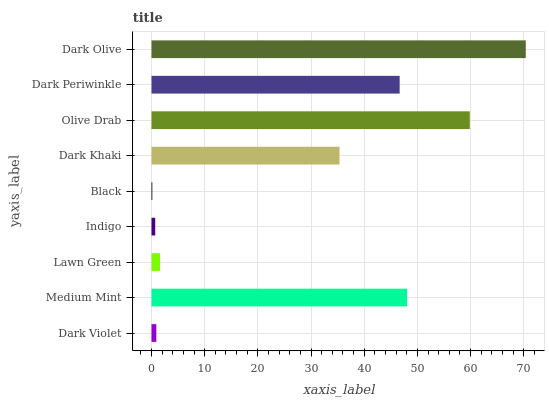Is Black the minimum?
Answer yes or no. Yes. Is Dark Olive the maximum?
Answer yes or no. Yes. Is Medium Mint the minimum?
Answer yes or no. No. Is Medium Mint the maximum?
Answer yes or no. No. Is Medium Mint greater than Dark Violet?
Answer yes or no. Yes. Is Dark Violet less than Medium Mint?
Answer yes or no. Yes. Is Dark Violet greater than Medium Mint?
Answer yes or no. No. Is Medium Mint less than Dark Violet?
Answer yes or no. No. Is Dark Khaki the high median?
Answer yes or no. Yes. Is Dark Khaki the low median?
Answer yes or no. Yes. Is Black the high median?
Answer yes or no. No. Is Indigo the low median?
Answer yes or no. No. 